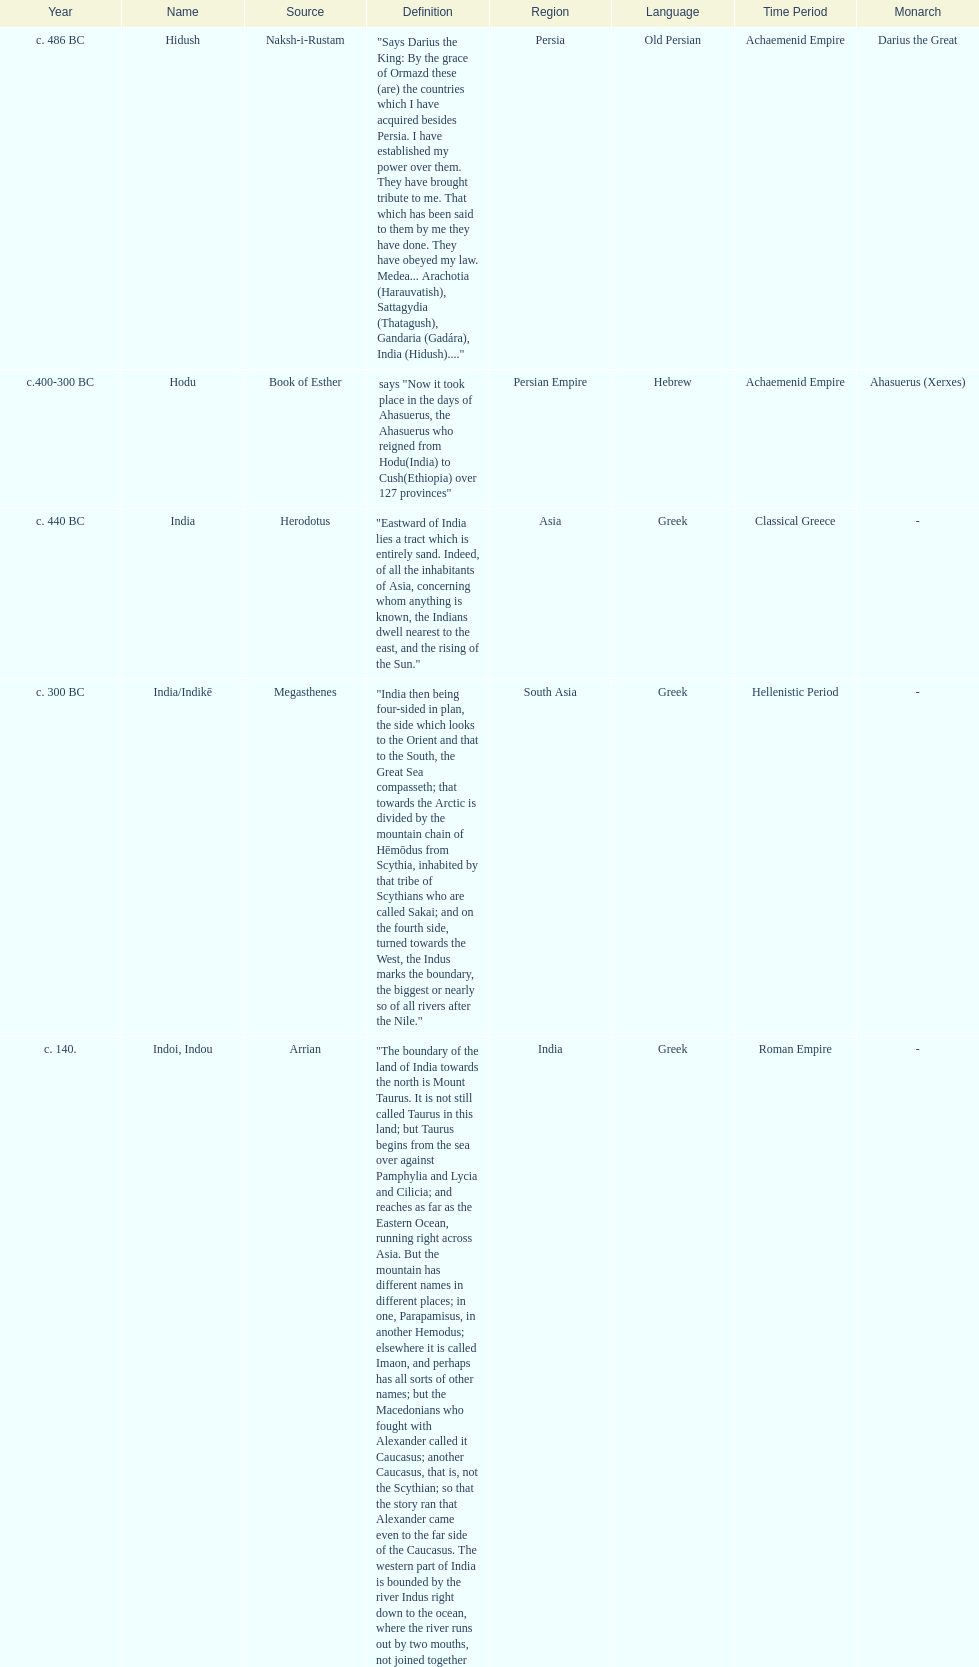What was the nation called before the book of esther called it hodu? Hidush. 